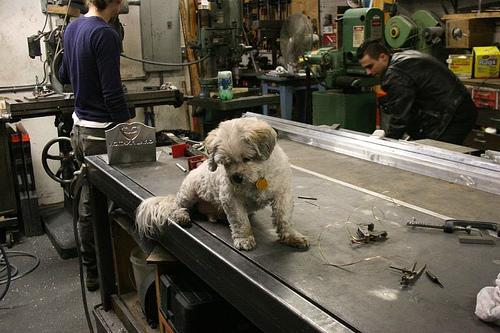What work is done in this space? Please explain your reasoning. machine shop. There are tools on the work surface. 